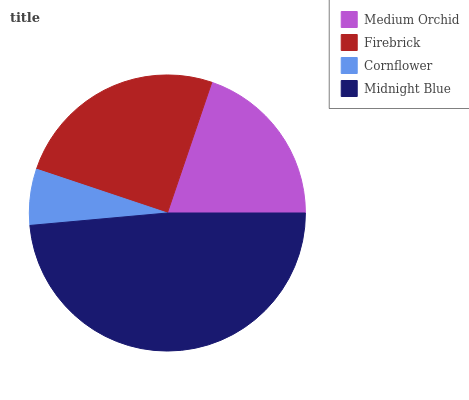Is Cornflower the minimum?
Answer yes or no. Yes. Is Midnight Blue the maximum?
Answer yes or no. Yes. Is Firebrick the minimum?
Answer yes or no. No. Is Firebrick the maximum?
Answer yes or no. No. Is Firebrick greater than Medium Orchid?
Answer yes or no. Yes. Is Medium Orchid less than Firebrick?
Answer yes or no. Yes. Is Medium Orchid greater than Firebrick?
Answer yes or no. No. Is Firebrick less than Medium Orchid?
Answer yes or no. No. Is Firebrick the high median?
Answer yes or no. Yes. Is Medium Orchid the low median?
Answer yes or no. Yes. Is Medium Orchid the high median?
Answer yes or no. No. Is Cornflower the low median?
Answer yes or no. No. 